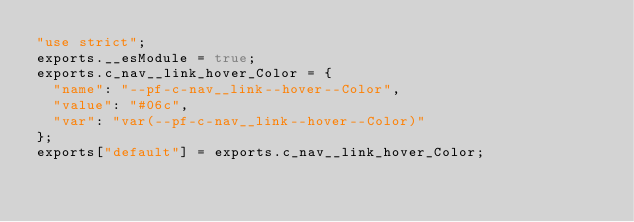Convert code to text. <code><loc_0><loc_0><loc_500><loc_500><_JavaScript_>"use strict";
exports.__esModule = true;
exports.c_nav__link_hover_Color = {
  "name": "--pf-c-nav__link--hover--Color",
  "value": "#06c",
  "var": "var(--pf-c-nav__link--hover--Color)"
};
exports["default"] = exports.c_nav__link_hover_Color;</code> 